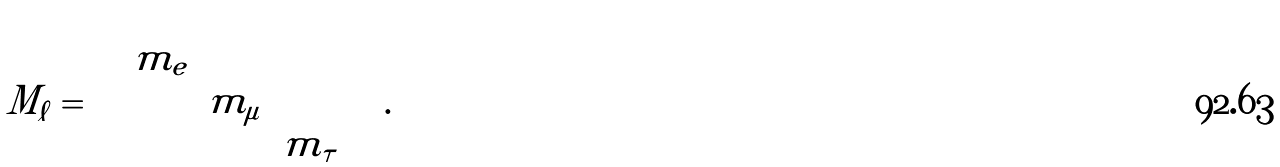Convert formula to latex. <formula><loc_0><loc_0><loc_500><loc_500>M _ { \ell } = \left ( \begin{array} { c c c } m _ { e } & & \\ & m _ { \mu } & \\ & & m _ { \tau } \end{array} \right ) .</formula> 